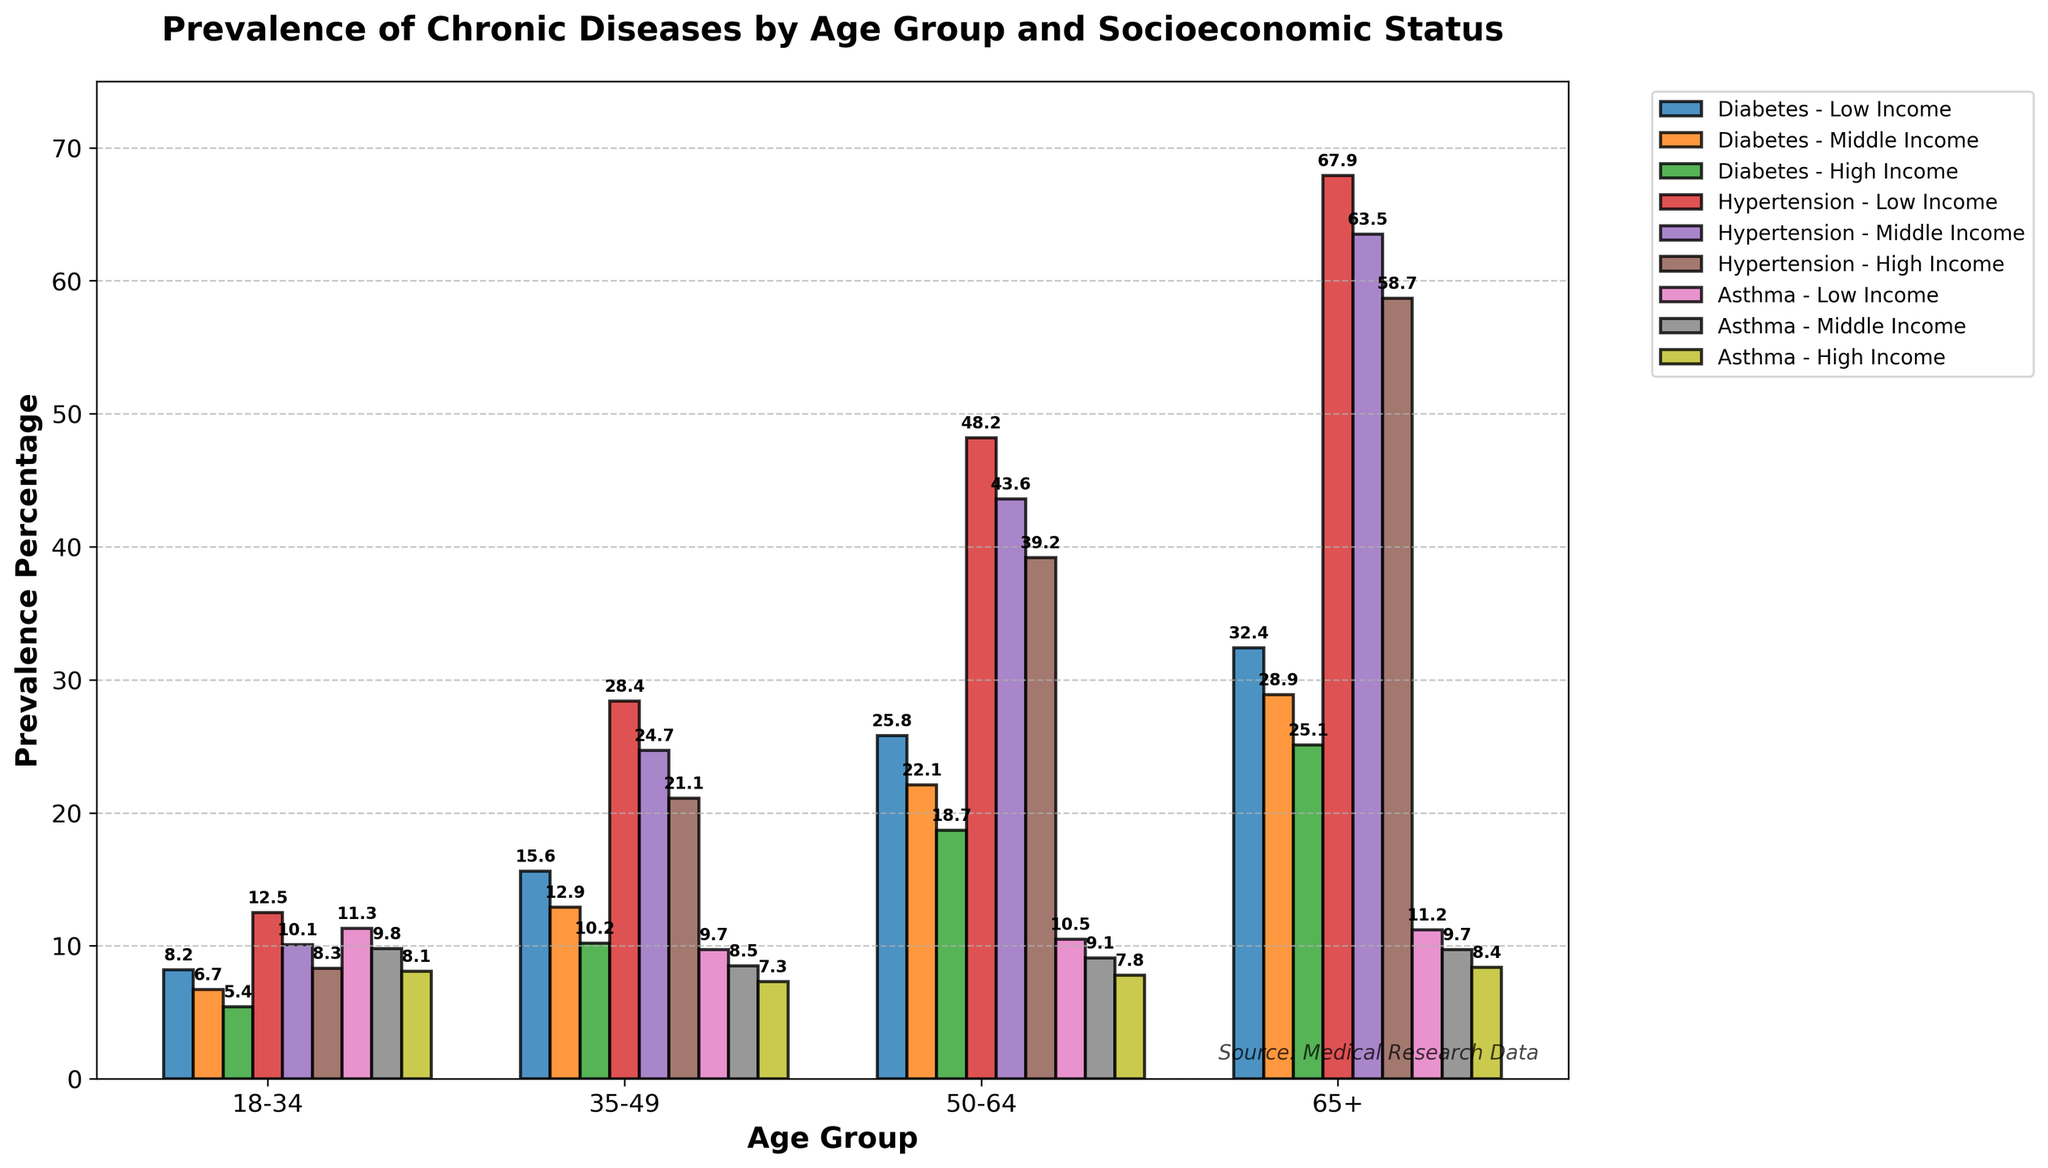What is the prevalence of Diabetes in the 18-34 age group for Low Income status? Identify the bar representing Diabetes in the 18-34 age group with Low Income status. The prevalence percentage is labeled on top of the bar.
Answer: 8.2% Which socioeconomic status has the highest prevalence of Hypertension in the 50-64 age group? Compare the heights of the bars representing Hypertension in the 50-64 age group across Low Income, Middle Income, and High Income statuses. The tallest bar indicates the highest prevalence.
Answer: Low Income What is the difference in Diabetes prevalence between 18-34 and 65+ age groups for Middle Income status? Locate the bars for Diabetes within the 18-34 and 65+ age groups for Middle Income status. Subtract the prevalence percentage of the younger group from that of the older group.
Answer: 22.2% Which age group has the lowest prevalence of Asthma in High Income status? Compare the heights of the bars representing Asthma in High Income status across all age groups. Identify the age group with the shortest bar.
Answer: 50-64 How does the prevalence of Hypertension change with age for Low Income status? Observe the trend in heights of the bars representing Hypertension in Low Income status as age increases from 18-34 to 65+. Note the general pattern of increase or decrease.
Answer: Increases For the 35-49 age group, which chronic disease has the lowest prevalence in Middle Income status? Compare the bars representing different chronic diseases in the 35-49 age group for Middle Income status. Identify the disease associated with the shortest bar.
Answer: Asthma What is the average prevalence of Diabetes across all age groups for High Income status? Sum the prevalence percentages of Diabetes for High Income status across all age groups and divide by the number of age groups (4). (5.4 + 10.2 + 18.7 + 25.1)/4 = 14.85
Answer: 14.85% Is the prevalence of Asthma higher in the 18-34 age group for Middle Income status or High Income status? Compare the heights of the bars representing Asthma in the 18-34 age group for Middle Income and High Income statuses. The taller bar indicates a higher prevalence.
Answer: Middle Income What is the total prevalence of Hypertension in the 65+ age group for all socioeconomic statuses combined? Add the prevalence percentages of Hypertension in the 65+ age group for Low Income, Middle Income, and High Income statuses. 67.9 + 63.5 + 58.7 = 190.1
Answer: 190.1% How does the prevalence of chronic diseases in Low Income status for the 18-34 age group compare to that of Middle Income status in the same age group? Compare the heights of corresponding bars for each chronic disease in the 18-34 age group between Low Income and Middle Income statuses. Note which status has higher or lower values for each disease.
Answer: Low Income generally higher 